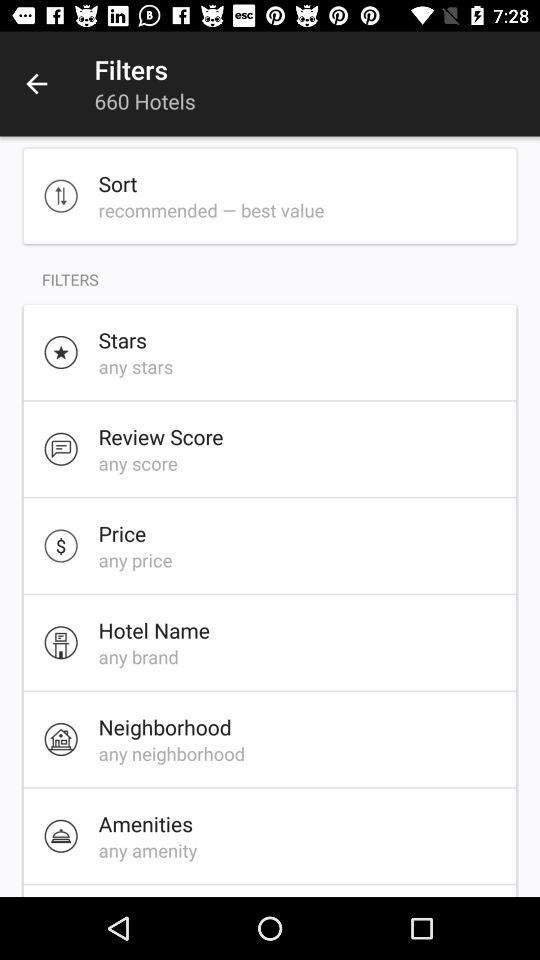What is the hotel name selected? The selected hotel name is "any brand". 